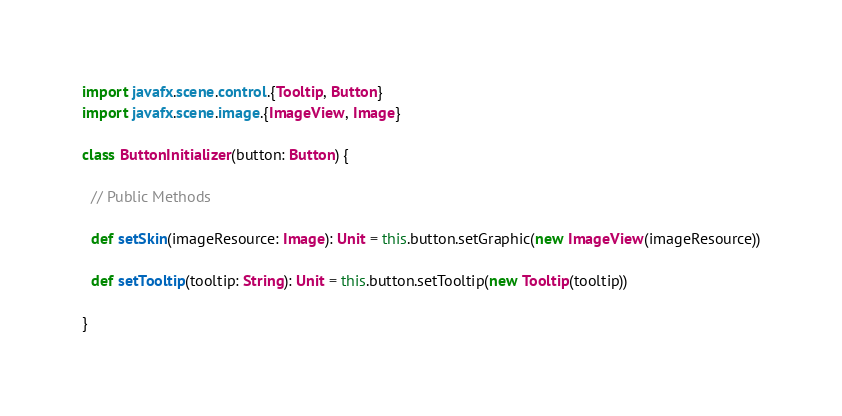<code> <loc_0><loc_0><loc_500><loc_500><_Scala_>
import javafx.scene.control.{Tooltip, Button}
import javafx.scene.image.{ImageView, Image}

class ButtonInitializer(button: Button) {

  // Public Methods

  def setSkin(imageResource: Image): Unit = this.button.setGraphic(new ImageView(imageResource))

  def setTooltip(tooltip: String): Unit = this.button.setTooltip(new Tooltip(tooltip))

}
</code> 